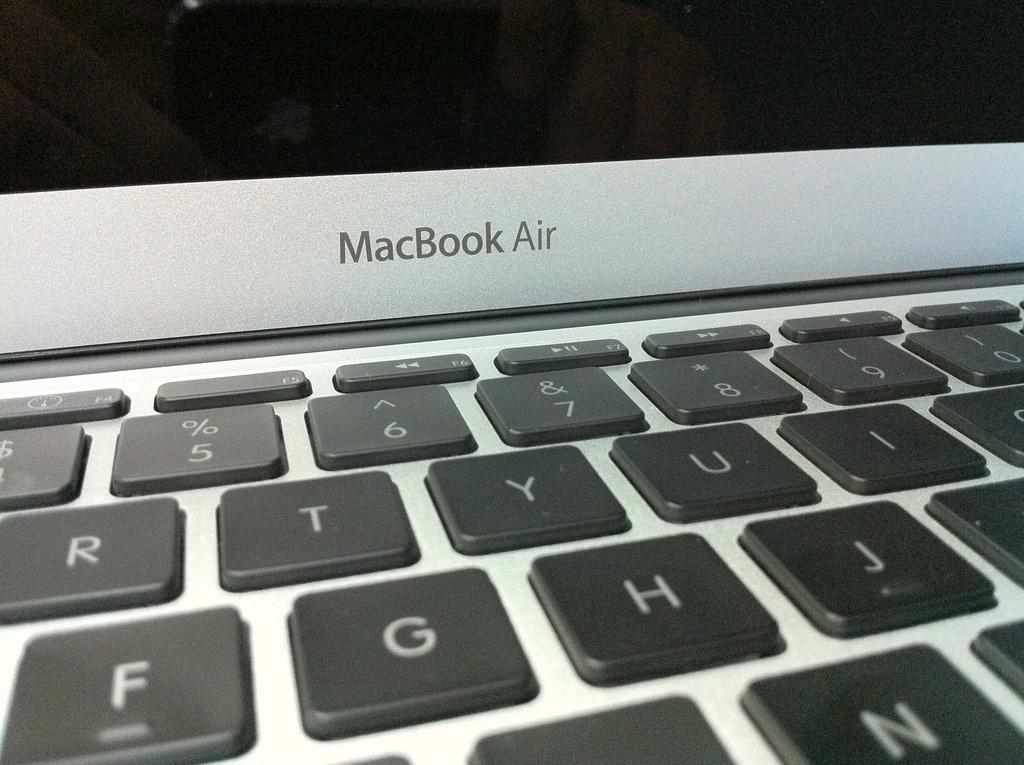<image>
Summarize the visual content of the image. A MacBook Air keyboard and screen is on display 